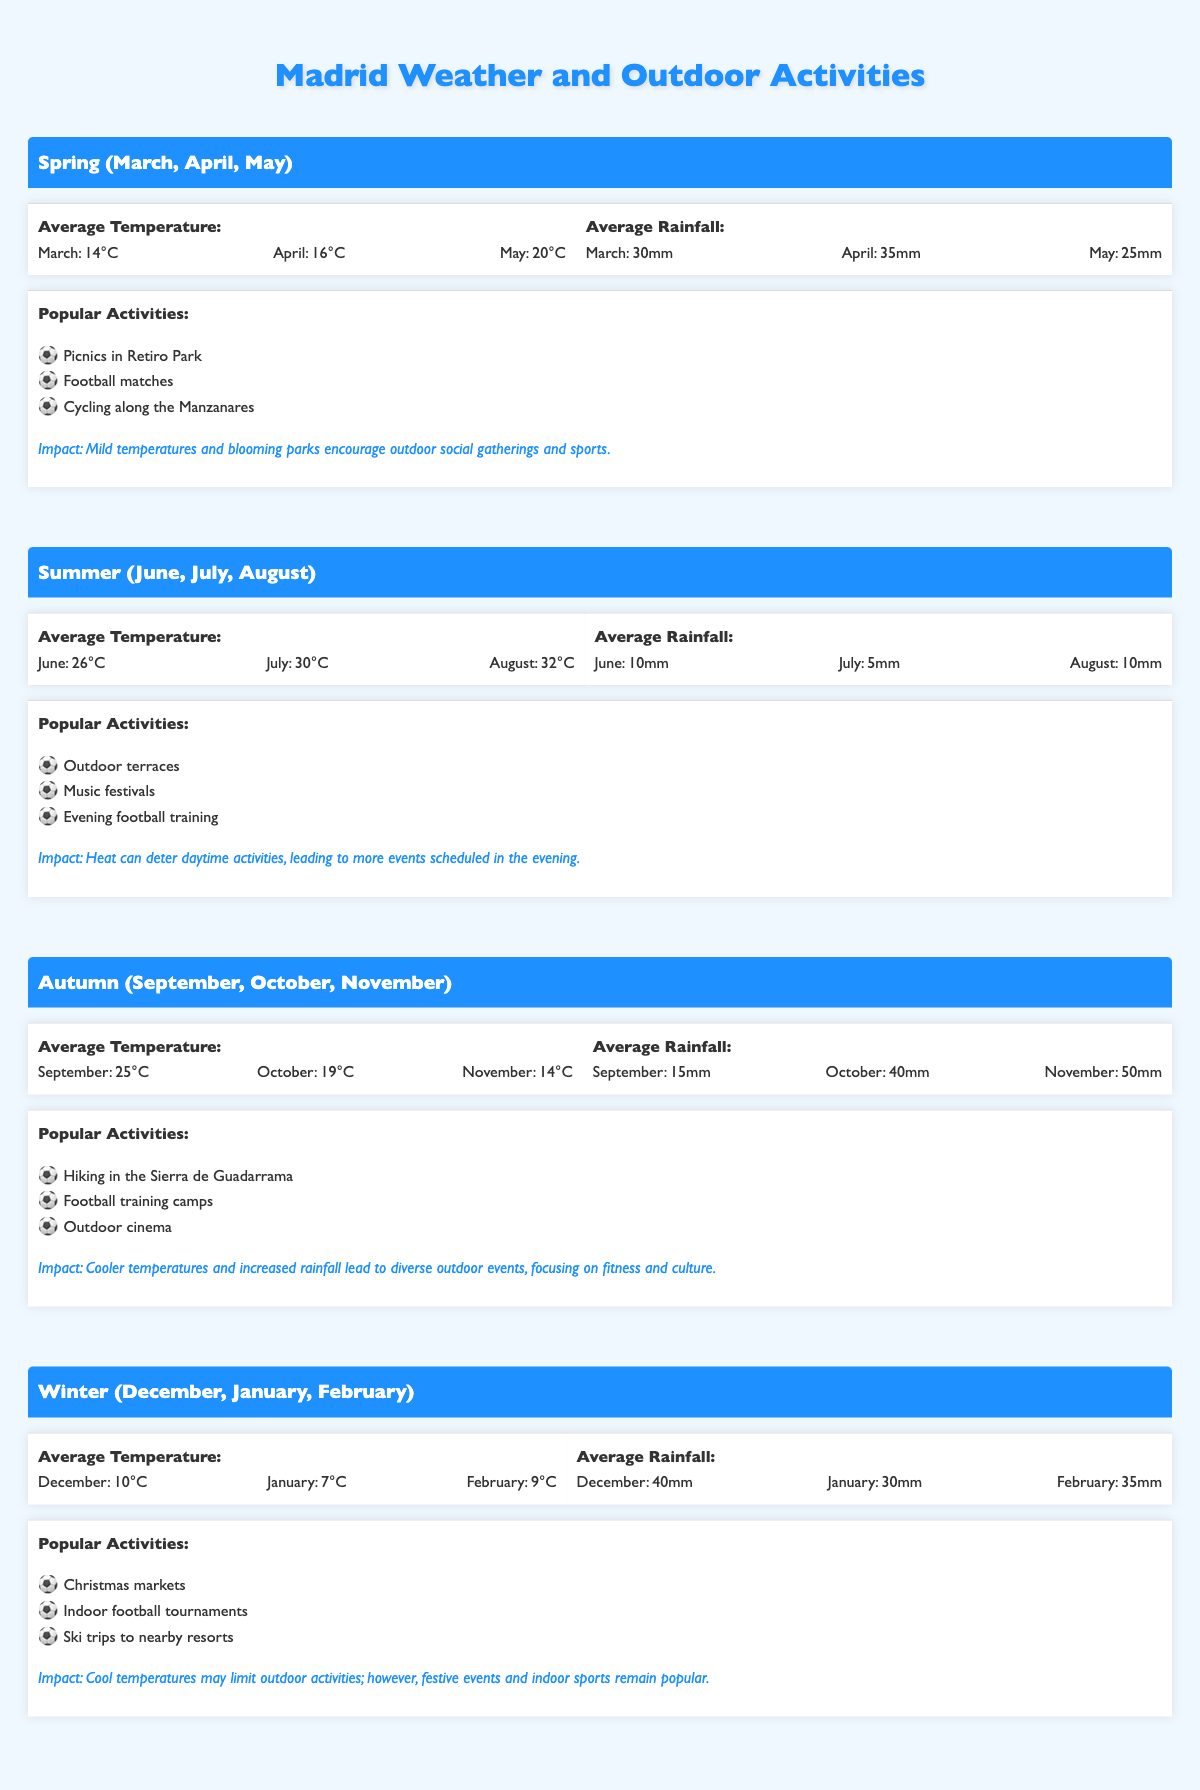What is the average temperature in May? The table shows that the average temperature in May is 20°C under the Spring section.
Answer: 20°C Which season has the most rainfall in November? The table indicates that November falls under the Autumn season, which has 50mm of rainfall, the highest for that month.
Answer: Autumn with 50mm Are indoor football tournaments popular during Winter? According to the table, indoor football tournaments are listed as one of the popular activities during the Winter season.
Answer: Yes What is the sum of the average rainfall for April and October? The average rainfall for April is 35mm and for October is 40mm. Adding these two values gives 35 + 40 = 75mm.
Answer: 75mm In which season is evening football training popular? The Summer season lists evening football training as a popular activity, particularly due to the heat during the day.
Answer: Summer Do cooler temperatures in Autumn lead to less outdoor activity? The Autumn section states that cooler temperatures and increased rainfall lead to diverse outdoor events, indicating that activities are not necessarily less.
Answer: No What is the average temperature during Winter? The average temperatures for Winter are December (10°C), January (7°C), and February (9°C). To find the average, we add these temperatures: (10 + 7 + 9) / 3 = 26 / 3 = approximately 8.67°C.
Answer: Approximately 8.67°C How does the impact of Spring weather on outdoor activities differ from Winter? The Spring impact mentions mild temperatures and blooming parks encouraging social gatherings and sports, while Winter indicates that cool temperatures limit outdoor activities but festive events remain popular.
Answer: Spring promotes activities, Winter limits them 